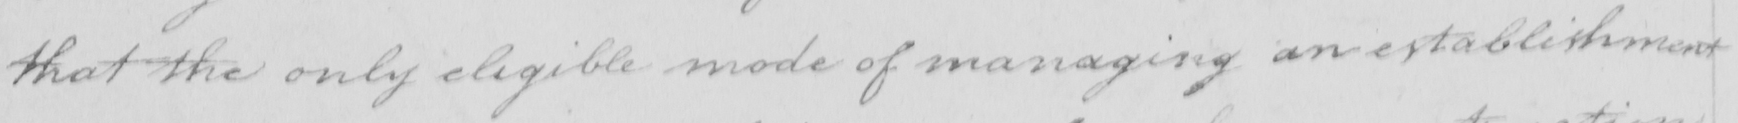Can you tell me what this handwritten text says? that the only eligible mode of managing an establishment 